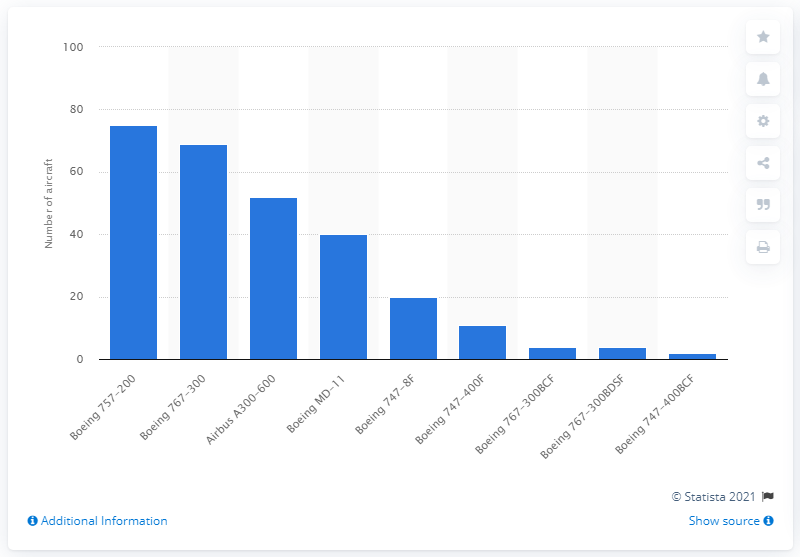Indicate a few pertinent items in this graphic. The Boeing 757-200 aircraft were 75 in the United Parcel Service of America's fleet as of December 31, 2020. 